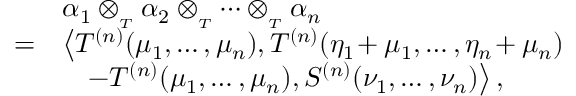Convert formula to latex. <formula><loc_0><loc_0><loc_500><loc_500>\begin{array} { r l } & { \alpha _ { 1 } \otimes _ { _ { T } } \alpha _ { 2 } \otimes _ { _ { T } } \cdots \otimes _ { _ { T } } \alpha _ { n } } \\ { = } & { \left \langle T ^ { ( n ) } ( \mu _ { 1 } , \dots , \mu _ { n } ) , T ^ { ( n ) } ( \eta _ { 1 } \, + \mu _ { 1 } , \dots , \eta _ { n } \, + \mu _ { n } ) } \\ & { \quad \, - T ^ { ( n ) } ( \mu _ { 1 } , \dots , \mu _ { n } ) , S ^ { ( n ) } ( \nu _ { 1 } , \dots , \nu _ { n } ) \right \rangle , } \end{array}</formula> 